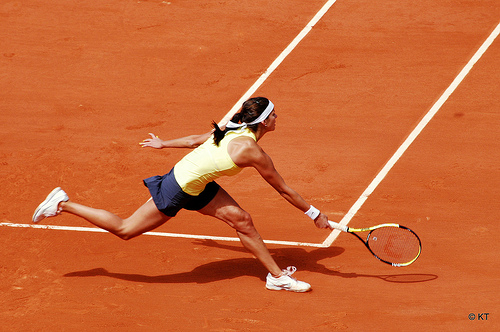Does that shirt look yellow? Yes, the shirt indeed looks bright yellow, a common choice for outdoor activities for better visibility. 